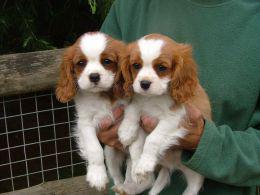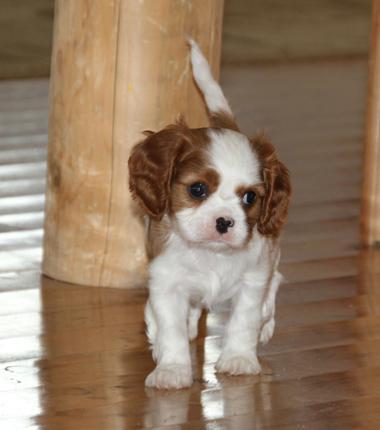The first image is the image on the left, the second image is the image on the right. Assess this claim about the two images: "There are two dogs looking directly at the camera.". Correct or not? Answer yes or no. No. The first image is the image on the left, the second image is the image on the right. For the images shown, is this caption "An image shows a brown and white spaniel puppy on a varnished wood floor." true? Answer yes or no. Yes. 